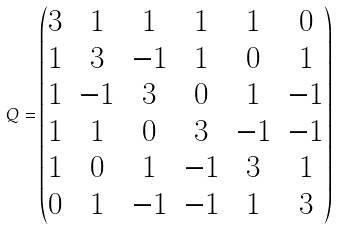Convert formula to latex. <formula><loc_0><loc_0><loc_500><loc_500>Q = \begin{pmatrix} 3 & 1 & 1 & 1 & 1 & 0 \\ 1 & 3 & - 1 & 1 & 0 & 1 \\ 1 & - 1 & 3 & 0 & 1 & - 1 \\ 1 & 1 & 0 & 3 & - 1 & - 1 \\ 1 & 0 & 1 & - 1 & 3 & 1 \\ 0 & 1 & - 1 & - 1 & 1 & 3 \end{pmatrix}</formula> 